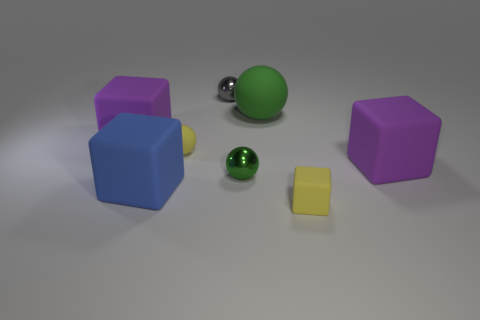Subtract all big matte blocks. How many blocks are left? 1 Subtract all gray spheres. How many spheres are left? 3 Subtract 2 balls. How many balls are left? 2 Add 1 yellow spheres. How many objects exist? 9 Subtract all brown cubes. How many green spheres are left? 2 Subtract all blue matte blocks. Subtract all big blue matte things. How many objects are left? 6 Add 8 big green matte objects. How many big green matte objects are left? 9 Add 8 small red cubes. How many small red cubes exist? 8 Subtract 1 gray spheres. How many objects are left? 7 Subtract all cyan cubes. Subtract all green cylinders. How many cubes are left? 4 